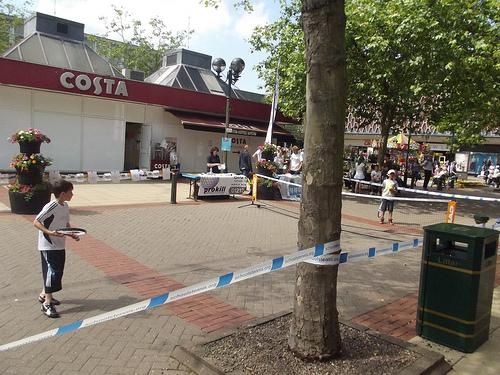What type of clothing is the small boy wearing and what is he doing? The small boy is wearing a white hat and he is standing. What kind of sentiment is evoked by the image of the boys playing in the outdoor shopping mall? The sentiment evoked is joyful due to boys playing tennis on a makeshift tennis court in an outdoor shopping mall. Describe the objects found close to the tree trunk in the image. A tree log, bark on the tree, and a tree well formed by cement bricks are close to the tree trunk. Identify the colors of the frisbee held by the kid and the tape on the tree. The frisbee is white and the tape on the tree is blue and white striped. What type of tree is in the image and mention its physical features. There is a large green tree with full leaves, with a very large trunk featuring a bark on it. How many boys are wearing blue shorts and what are they doing? There is one boy wearing blue shorts and he is holding a frisbee. What does the banner by the makeshift tennis court represent? The banner represents a sponsor for the makeshift tennis court. Is there any writing on the building, if yes, what does it say? Yes, there is writing on the building, it says "Costa". Mention the objects present in a tiered outdoor flower planter. Flowers in pots are present in the tiered outdoor flower planter. Count the number of trees present in the image, and describe their characteristics. There are two trees, one is large with full leaves while the other one has leaves growing only on the top. 